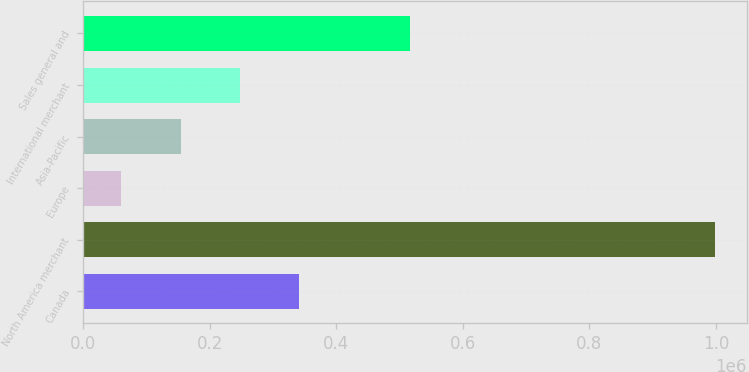Convert chart to OTSL. <chart><loc_0><loc_0><loc_500><loc_500><bar_chart><fcel>Canada<fcel>North America merchant<fcel>Europe<fcel>Asia-Pacific<fcel>International merchant<fcel>Sales general and<nl><fcel>341384<fcel>998463<fcel>59778<fcel>153646<fcel>247515<fcel>515751<nl></chart> 